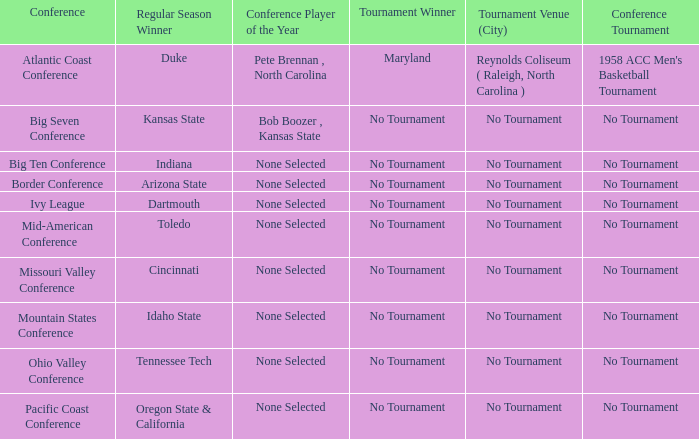Who won the tournament when Idaho State won the regular season? No Tournament. 